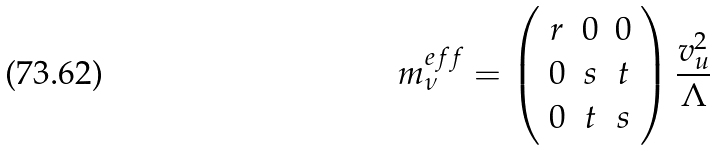<formula> <loc_0><loc_0><loc_500><loc_500>m ^ { e f f } _ { \nu } = \left ( \begin{array} { c c c } r & 0 & 0 \\ 0 & s & t \\ 0 & t & s \end{array} \right ) \frac { v ^ { 2 } _ { u } } { \Lambda }</formula> 